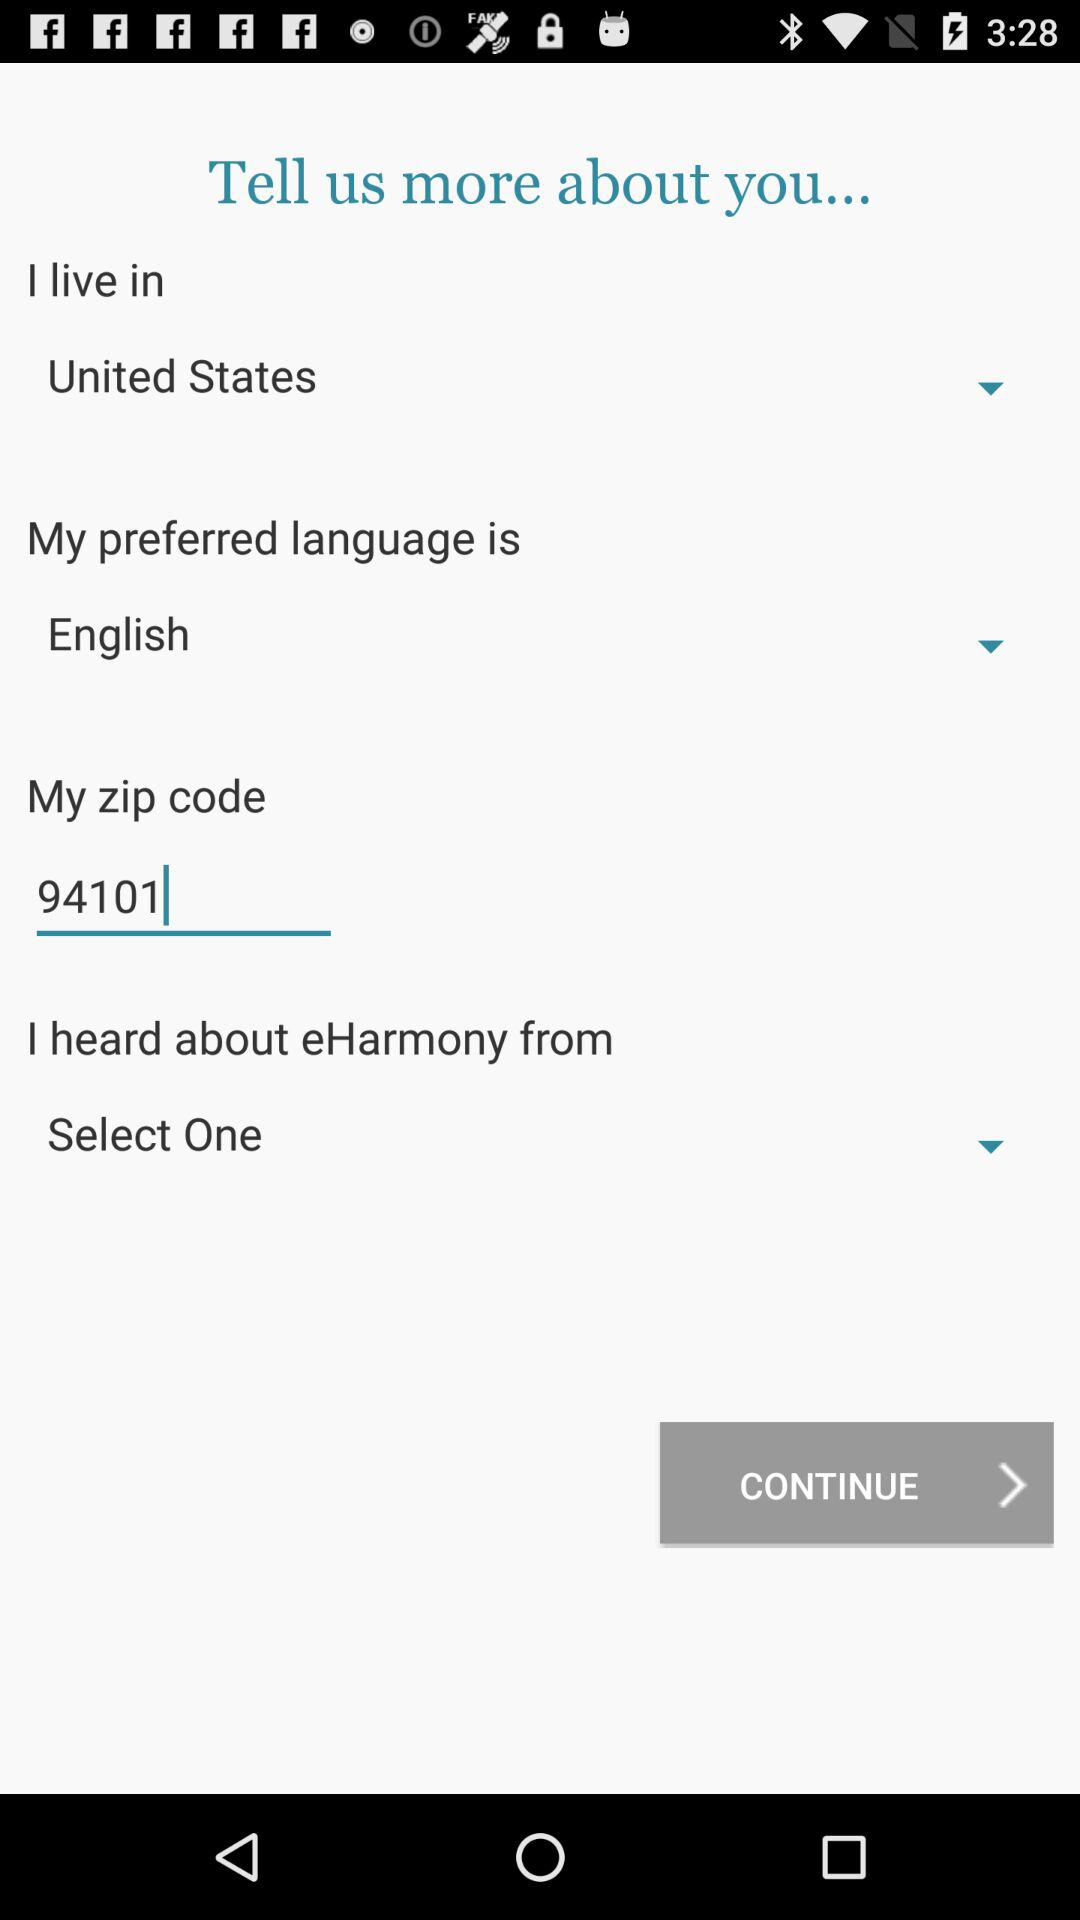What is the zip code? The zip code is 94101. 